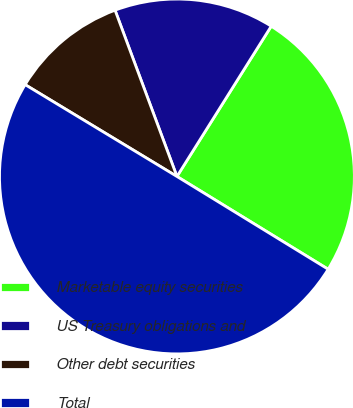Convert chart to OTSL. <chart><loc_0><loc_0><loc_500><loc_500><pie_chart><fcel>Marketable equity securities<fcel>US Treasury obligations and<fcel>Other debt securities<fcel>Total<nl><fcel>24.84%<fcel>14.59%<fcel>10.67%<fcel>49.9%<nl></chart> 